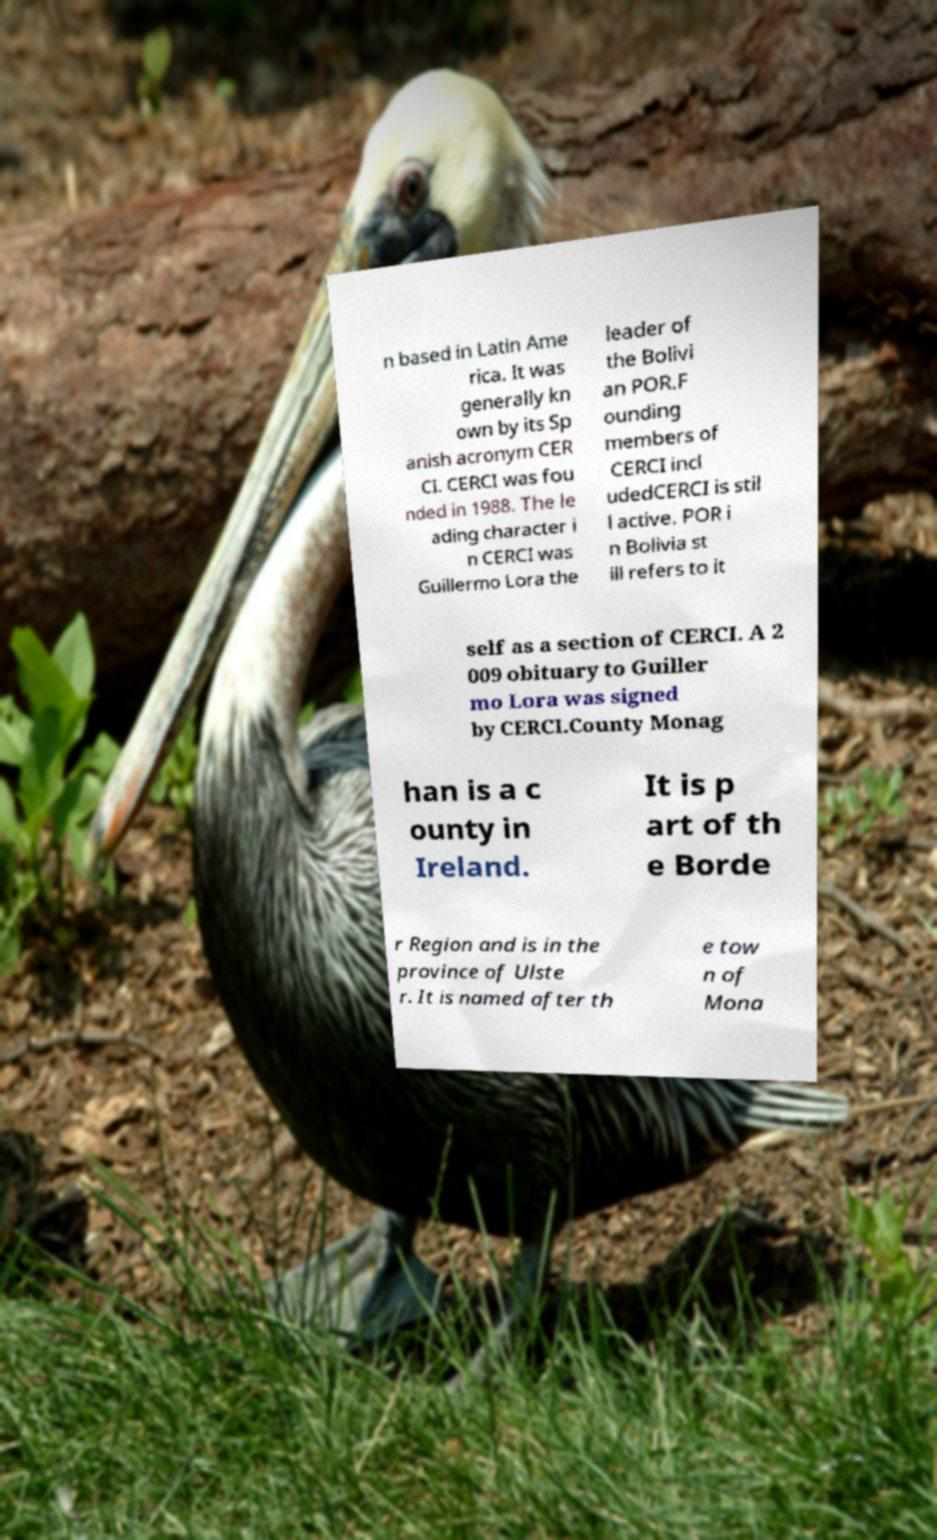Can you read and provide the text displayed in the image?This photo seems to have some interesting text. Can you extract and type it out for me? n based in Latin Ame rica. It was generally kn own by its Sp anish acronym CER CI. CERCI was fou nded in 1988. The le ading character i n CERCI was Guillermo Lora the leader of the Bolivi an POR.F ounding members of CERCI incl udedCERCI is stil l active. POR i n Bolivia st ill refers to it self as a section of CERCI. A 2 009 obituary to Guiller mo Lora was signed by CERCI.County Monag han is a c ounty in Ireland. It is p art of th e Borde r Region and is in the province of Ulste r. It is named after th e tow n of Mona 